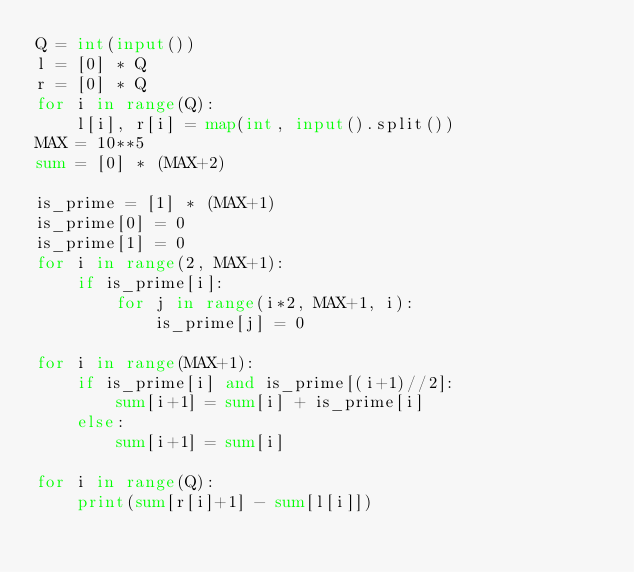Convert code to text. <code><loc_0><loc_0><loc_500><loc_500><_Python_>Q = int(input())
l = [0] * Q
r = [0] * Q
for i in range(Q):
    l[i], r[i] = map(int, input().split())
MAX = 10**5
sum = [0] * (MAX+2)

is_prime = [1] * (MAX+1)
is_prime[0] = 0
is_prime[1] = 0
for i in range(2, MAX+1):
    if is_prime[i]:
        for j in range(i*2, MAX+1, i):
            is_prime[j] = 0

for i in range(MAX+1):
    if is_prime[i] and is_prime[(i+1)//2]:
        sum[i+1] = sum[i] + is_prime[i]
    else:
        sum[i+1] = sum[i]
        
for i in range(Q):
    print(sum[r[i]+1] - sum[l[i]])
</code> 